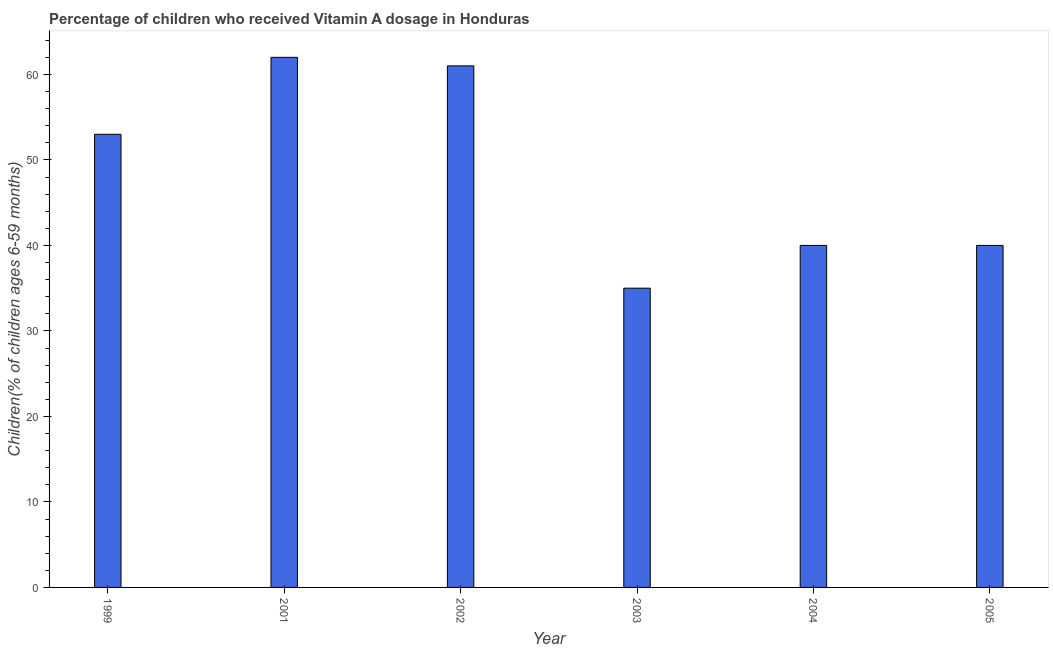What is the title of the graph?
Offer a very short reply. Percentage of children who received Vitamin A dosage in Honduras. What is the label or title of the Y-axis?
Your response must be concise. Children(% of children ages 6-59 months). What is the vitamin a supplementation coverage rate in 2002?
Ensure brevity in your answer.  61. Across all years, what is the minimum vitamin a supplementation coverage rate?
Offer a terse response. 35. What is the sum of the vitamin a supplementation coverage rate?
Offer a very short reply. 291. What is the median vitamin a supplementation coverage rate?
Provide a short and direct response. 46.5. Do a majority of the years between 2002 and 2001 (inclusive) have vitamin a supplementation coverage rate greater than 12 %?
Make the answer very short. No. What is the ratio of the vitamin a supplementation coverage rate in 1999 to that in 2004?
Provide a short and direct response. 1.32. In how many years, is the vitamin a supplementation coverage rate greater than the average vitamin a supplementation coverage rate taken over all years?
Your response must be concise. 3. How many years are there in the graph?
Ensure brevity in your answer.  6. What is the Children(% of children ages 6-59 months) in 1999?
Your answer should be compact. 53. What is the Children(% of children ages 6-59 months) of 2002?
Your answer should be compact. 61. What is the Children(% of children ages 6-59 months) of 2005?
Your response must be concise. 40. What is the difference between the Children(% of children ages 6-59 months) in 1999 and 2003?
Provide a short and direct response. 18. What is the difference between the Children(% of children ages 6-59 months) in 1999 and 2004?
Your answer should be compact. 13. What is the difference between the Children(% of children ages 6-59 months) in 2001 and 2002?
Offer a very short reply. 1. What is the difference between the Children(% of children ages 6-59 months) in 2001 and 2004?
Ensure brevity in your answer.  22. What is the difference between the Children(% of children ages 6-59 months) in 2001 and 2005?
Ensure brevity in your answer.  22. What is the difference between the Children(% of children ages 6-59 months) in 2002 and 2003?
Keep it short and to the point. 26. What is the difference between the Children(% of children ages 6-59 months) in 2002 and 2005?
Your response must be concise. 21. What is the difference between the Children(% of children ages 6-59 months) in 2003 and 2005?
Ensure brevity in your answer.  -5. What is the ratio of the Children(% of children ages 6-59 months) in 1999 to that in 2001?
Offer a very short reply. 0.85. What is the ratio of the Children(% of children ages 6-59 months) in 1999 to that in 2002?
Your answer should be compact. 0.87. What is the ratio of the Children(% of children ages 6-59 months) in 1999 to that in 2003?
Provide a succinct answer. 1.51. What is the ratio of the Children(% of children ages 6-59 months) in 1999 to that in 2004?
Ensure brevity in your answer.  1.32. What is the ratio of the Children(% of children ages 6-59 months) in 1999 to that in 2005?
Offer a terse response. 1.32. What is the ratio of the Children(% of children ages 6-59 months) in 2001 to that in 2003?
Offer a very short reply. 1.77. What is the ratio of the Children(% of children ages 6-59 months) in 2001 to that in 2004?
Provide a short and direct response. 1.55. What is the ratio of the Children(% of children ages 6-59 months) in 2001 to that in 2005?
Keep it short and to the point. 1.55. What is the ratio of the Children(% of children ages 6-59 months) in 2002 to that in 2003?
Ensure brevity in your answer.  1.74. What is the ratio of the Children(% of children ages 6-59 months) in 2002 to that in 2004?
Provide a succinct answer. 1.52. What is the ratio of the Children(% of children ages 6-59 months) in 2002 to that in 2005?
Offer a very short reply. 1.52. What is the ratio of the Children(% of children ages 6-59 months) in 2003 to that in 2004?
Provide a short and direct response. 0.88. What is the ratio of the Children(% of children ages 6-59 months) in 2003 to that in 2005?
Your answer should be compact. 0.88. What is the ratio of the Children(% of children ages 6-59 months) in 2004 to that in 2005?
Provide a short and direct response. 1. 